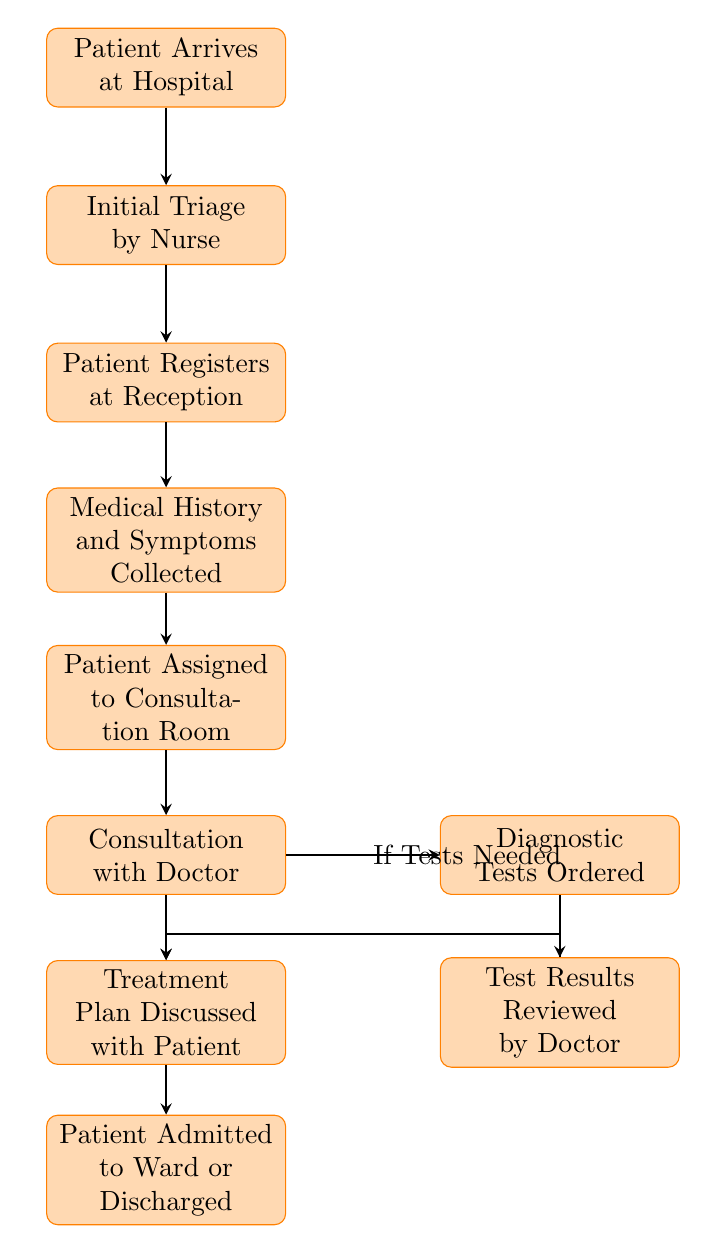What is the first step in the patient admission process? The first step in the diagram shows that the "Patient Arrives at Hospital" is at the top, indicating it's the starting point of the process.
Answer: Patient Arrives at Hospital How many processes are involved in the patient admission flowchart? By counting the nodes labeled with processes in the flowchart, there are a total of 10 different steps from arrival to admission or discharge.
Answer: 10 What happens after the initial triage by a nurse? Following the initial triage, the next step as shown in the diagram is that "Patient Registers at Reception." Hence, this is the immediate action that follows.
Answer: Patient Registers at Reception Which step involves the doctor discussing the treatment plan? The diagram indicates that the step where the treatment plan is discussed occurs after "Test Results Reviewed by Doctor" and before "Patient Admitted to Ward or Discharged." This step is labeled as "Treatment Plan Discussed with Patient."
Answer: Treatment Plan Discussed with Patient If diagnostic tests are needed, what is the next step? According to the flowchart, when the consultation with the doctor concludes, if tests are needed, the process flows to "Diagnostic Tests Ordered," indicating this action directly follows.
Answer: Diagnostic Tests Ordered Is there a direct connection between "Test Results Reviewed by Doctor" and the final step? Yes, the flowchart illustrates that the "Test Results Reviewed by Doctor" leads directly to the step where the "Treatment Plan Discussed with Patient," which is also part of the progression towards the final step.
Answer: Yes How many nodes are there in between patient arrival and admission or discharge? Starting from "Patient Arrives at Hospital" to "Patient Admitted to Ward or Discharged," there are 8 processes in between, indicating the various stages the patient goes through before the final outcome.
Answer: 8 What decision point is shown in the flowchart? The flowchart depicts a decision point at the consultation stage where it's determined "If Tests Needed." This decision influences the subsequent steps by leading to diagnostic tests if required.
Answer: If Tests Needed What is the last step of the patient admission process? The last step in the entire flow of the flowchart is labeled "Patient Admitted to Ward or Discharged," indicating the conclusion of the admission process based on prior conditions.
Answer: Patient Admitted to Ward or Discharged 